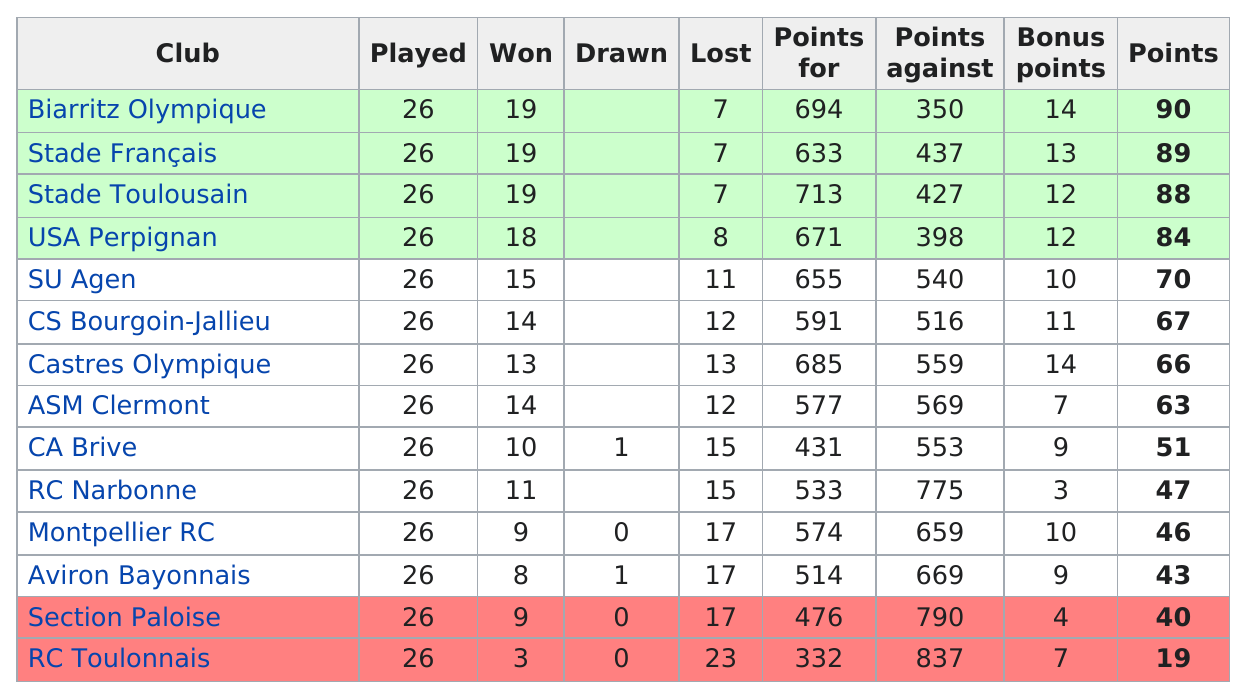Draw attention to some important aspects in this diagram. The team with more losses was RC Toulonnais. Out of the total 20 clubs, 9 clubs did not have any drawn results. RC Toulonnais had the highest number of losses out of 26 games. I declare that the club with the least amount of points is RC Toulonnais. SU Agen scored the most points among the three teams of SU Agén, Castres Olympique. 